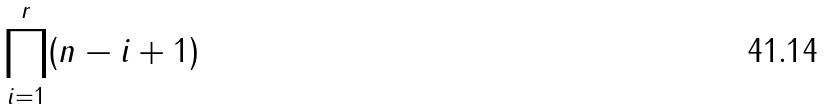<formula> <loc_0><loc_0><loc_500><loc_500>\prod _ { i = 1 } ^ { r } ( n - i + 1 )</formula> 